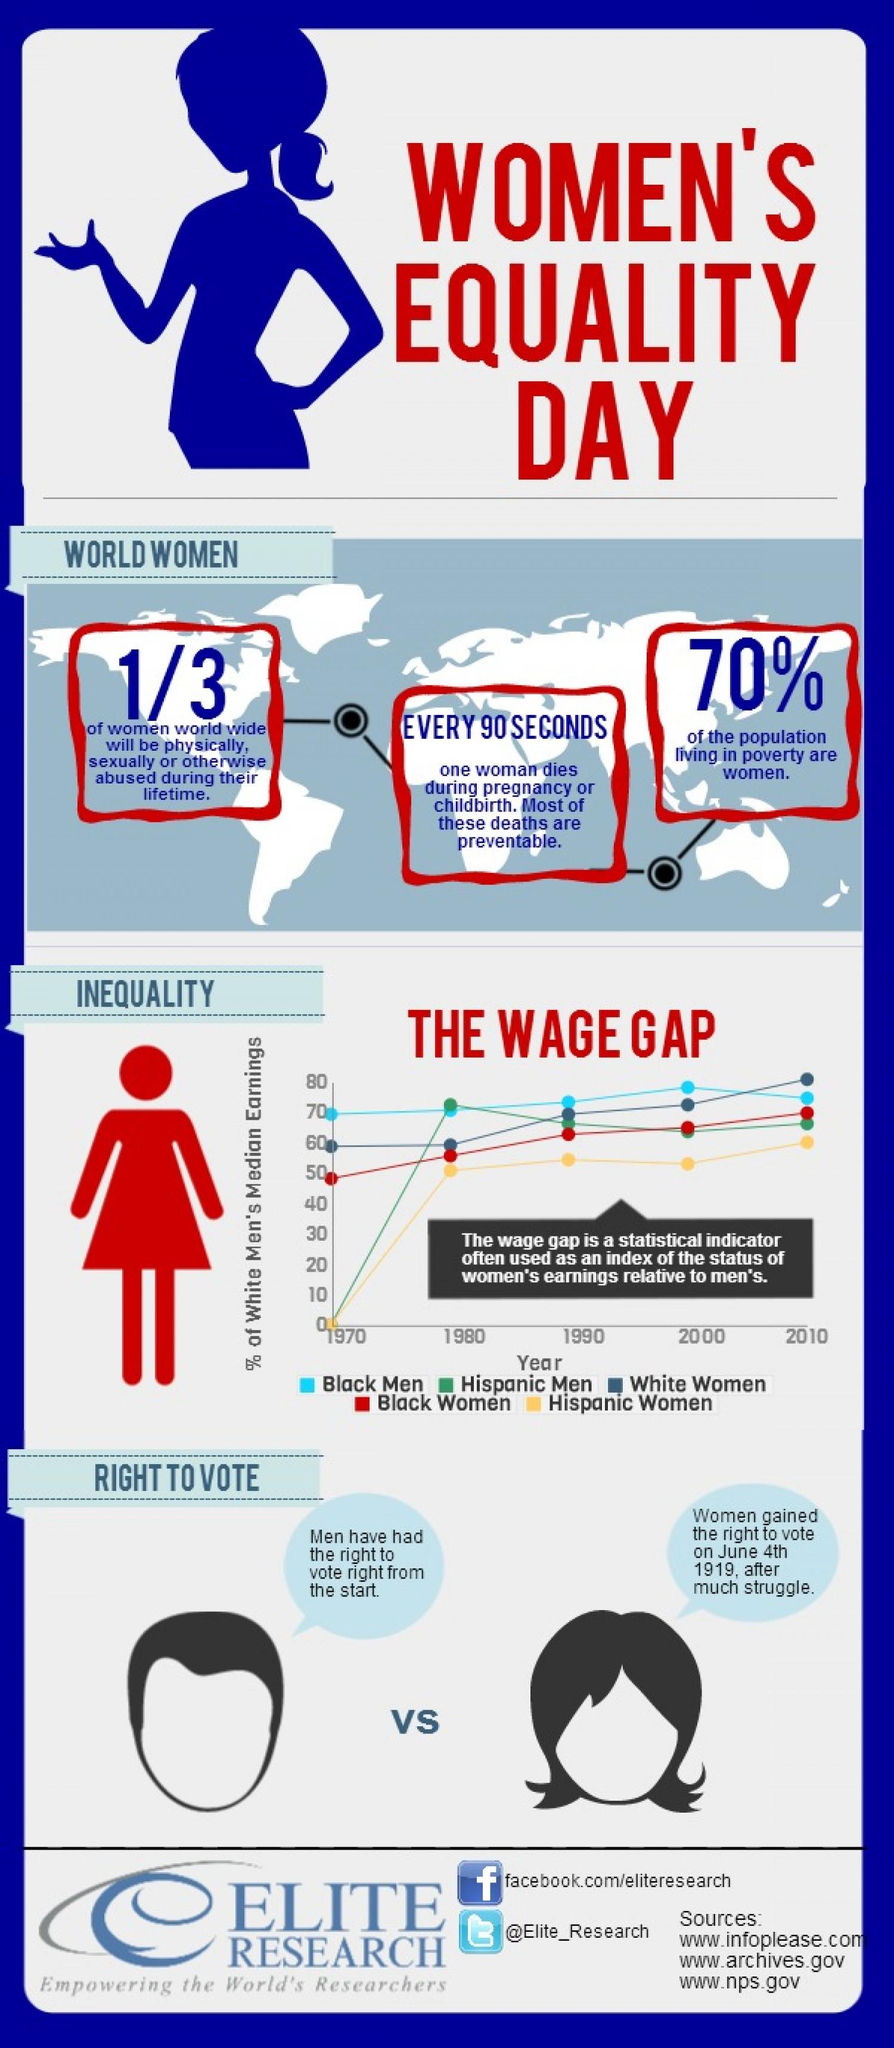Draw attention to some important aspects in this diagram. The wage gap graph represents Black women in red, yellow, or blue, depending on the color used to represent them, and it is currently represented in red. The Twitter handle "@Elite\_Research" has been provided. In the 1970s, certain groups of people, specifically Hispanic men and women, had their wages start at 0%. In the wage gap graph, the green line represents Hispanic men. There are three sources listed at the bottom. 